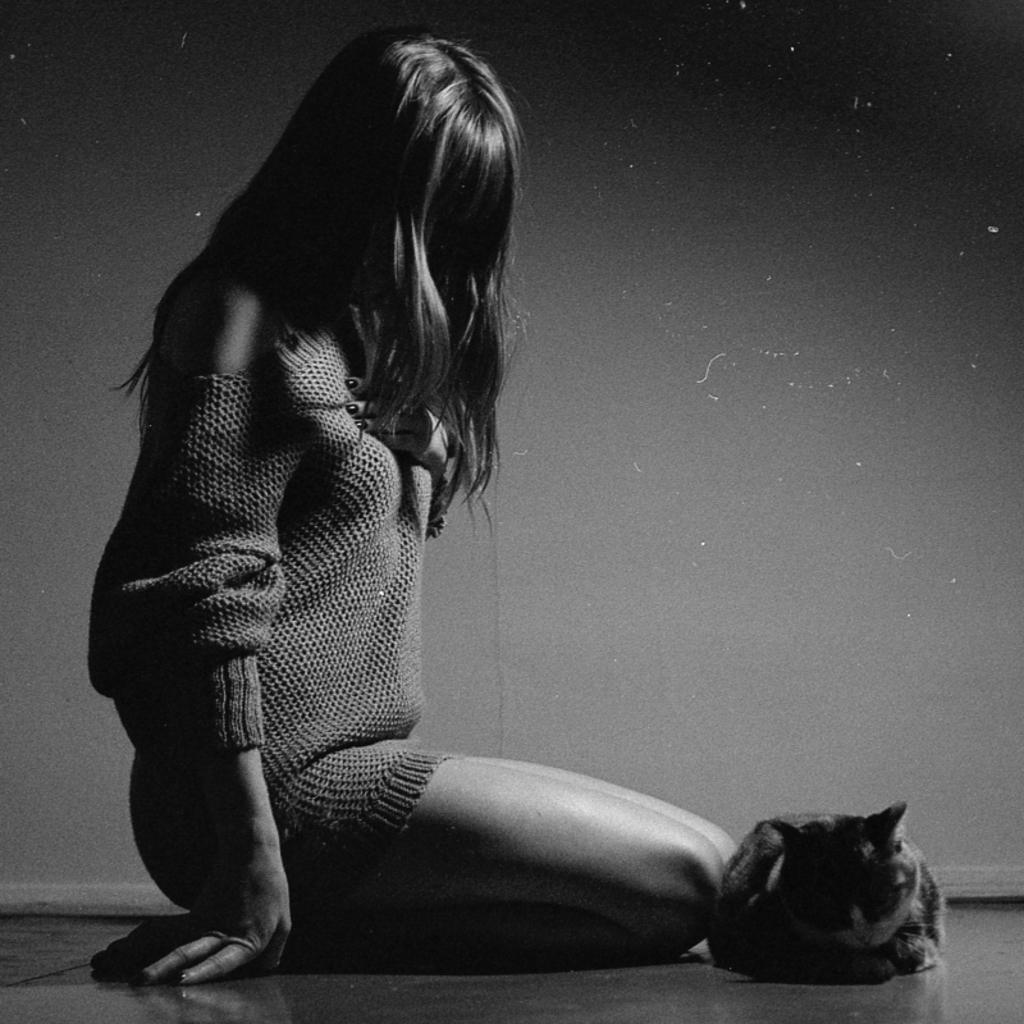How would you summarize this image in a sentence or two? In this picture a girl wearing a sweatshirt is sitting on the floor and a cat is sitting on the floor. 